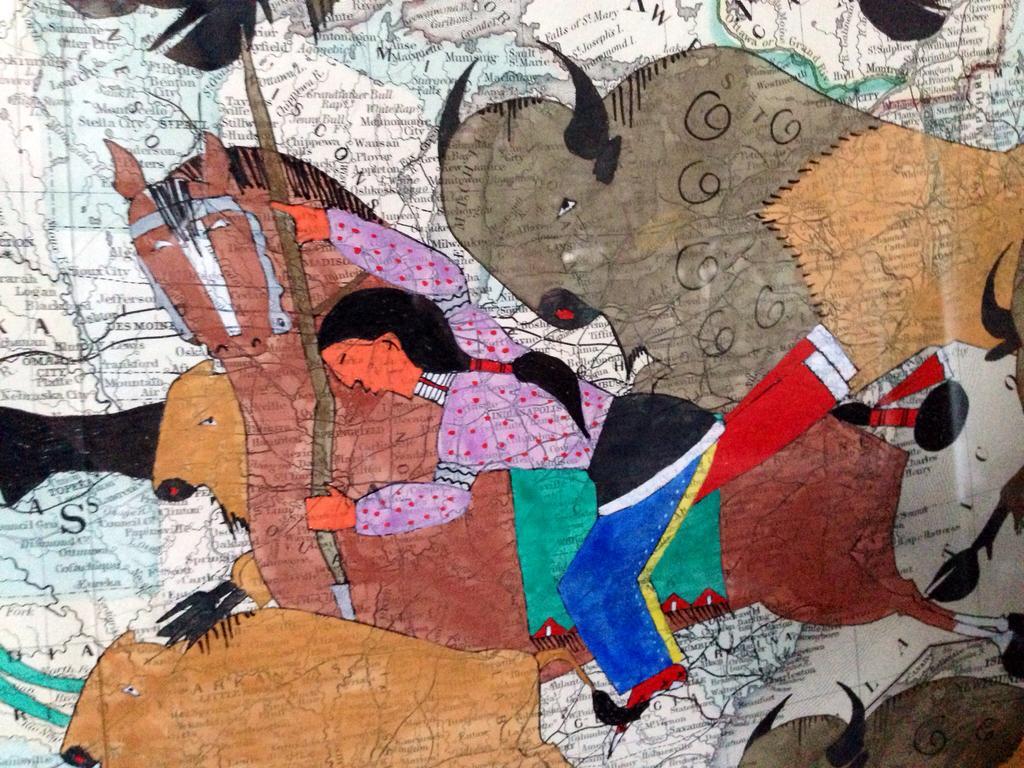In one or two sentences, can you explain what this image depicts? This is a painting. In this painting, there is a woman holding a stick and sitting on a horse. Beside this house, there are other animals. In the background, there are texts on a map. 